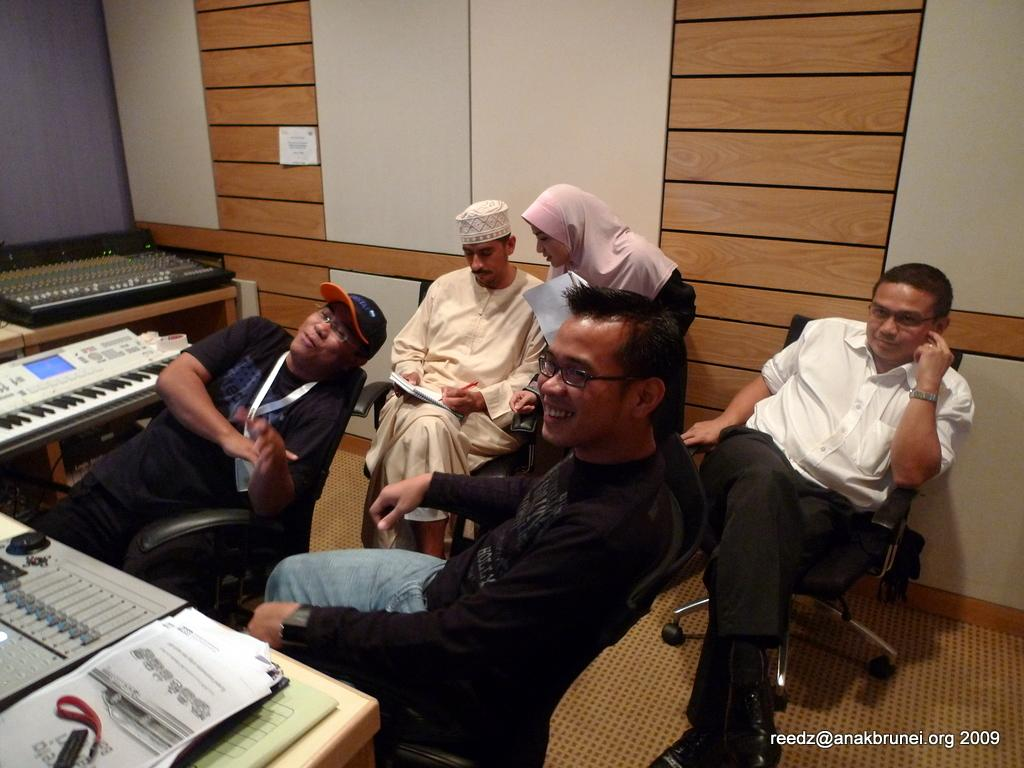How many people are sitting in the image? There are four people sitting on chairs in the image. What is the woman in the image doing? The woman is standing in the image. What objects are on the table in the image? There are musical instruments on a table in the image. What type of bag is hanging on the wall in the image? There is no bag present in the image. How many cans of soda are visible on the table in the image? There are no cans of soda visible in the image; only musical instruments are present on the table. 